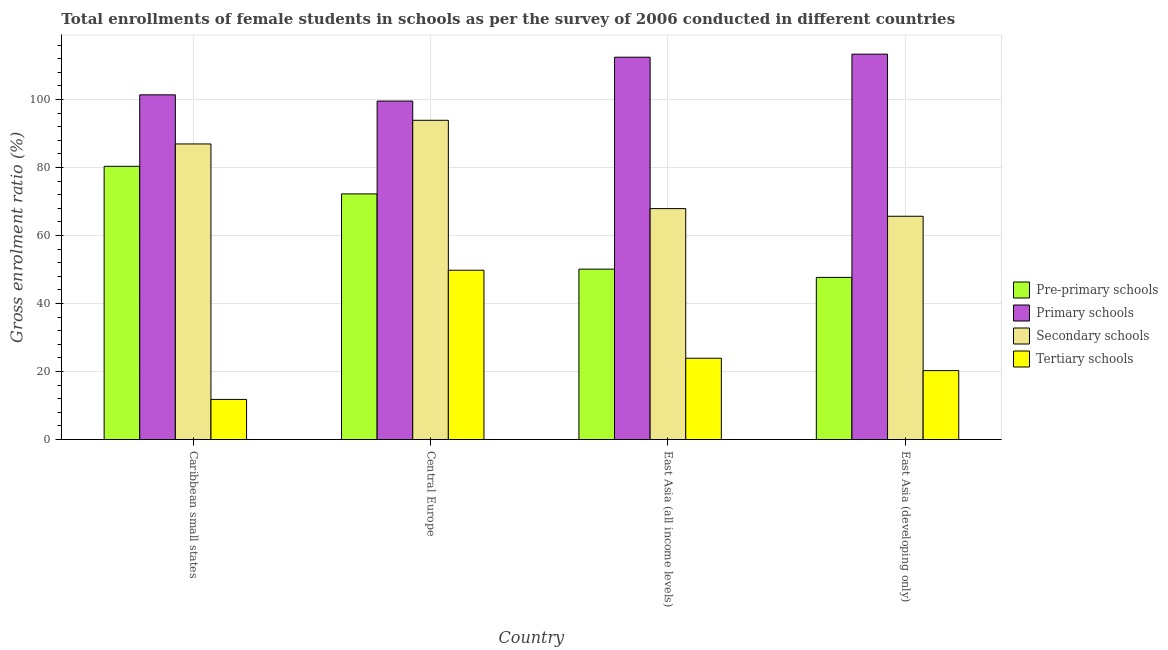Are the number of bars per tick equal to the number of legend labels?
Your answer should be very brief. Yes. How many bars are there on the 1st tick from the right?
Offer a very short reply. 4. What is the label of the 2nd group of bars from the left?
Your answer should be very brief. Central Europe. What is the gross enrolment ratio(female) in primary schools in Central Europe?
Ensure brevity in your answer.  99.56. Across all countries, what is the maximum gross enrolment ratio(female) in secondary schools?
Your answer should be compact. 93.9. Across all countries, what is the minimum gross enrolment ratio(female) in pre-primary schools?
Your response must be concise. 47.69. In which country was the gross enrolment ratio(female) in pre-primary schools maximum?
Ensure brevity in your answer.  Caribbean small states. In which country was the gross enrolment ratio(female) in pre-primary schools minimum?
Make the answer very short. East Asia (developing only). What is the total gross enrolment ratio(female) in tertiary schools in the graph?
Keep it short and to the point. 105.78. What is the difference between the gross enrolment ratio(female) in tertiary schools in Central Europe and that in East Asia (developing only)?
Keep it short and to the point. 29.52. What is the difference between the gross enrolment ratio(female) in primary schools in East Asia (developing only) and the gross enrolment ratio(female) in secondary schools in Central Europe?
Your answer should be very brief. 19.46. What is the average gross enrolment ratio(female) in pre-primary schools per country?
Your answer should be compact. 62.61. What is the difference between the gross enrolment ratio(female) in secondary schools and gross enrolment ratio(female) in primary schools in Caribbean small states?
Ensure brevity in your answer.  -14.45. In how many countries, is the gross enrolment ratio(female) in tertiary schools greater than 96 %?
Give a very brief answer. 0. What is the ratio of the gross enrolment ratio(female) in secondary schools in Caribbean small states to that in East Asia (developing only)?
Give a very brief answer. 1.32. Is the difference between the gross enrolment ratio(female) in tertiary schools in Caribbean small states and East Asia (all income levels) greater than the difference between the gross enrolment ratio(female) in secondary schools in Caribbean small states and East Asia (all income levels)?
Provide a succinct answer. No. What is the difference between the highest and the second highest gross enrolment ratio(female) in secondary schools?
Offer a very short reply. 6.96. What is the difference between the highest and the lowest gross enrolment ratio(female) in secondary schools?
Make the answer very short. 28.23. In how many countries, is the gross enrolment ratio(female) in tertiary schools greater than the average gross enrolment ratio(female) in tertiary schools taken over all countries?
Your response must be concise. 1. Is it the case that in every country, the sum of the gross enrolment ratio(female) in tertiary schools and gross enrolment ratio(female) in secondary schools is greater than the sum of gross enrolment ratio(female) in primary schools and gross enrolment ratio(female) in pre-primary schools?
Make the answer very short. No. What does the 3rd bar from the left in Central Europe represents?
Provide a short and direct response. Secondary schools. What does the 1st bar from the right in East Asia (developing only) represents?
Your response must be concise. Tertiary schools. How many countries are there in the graph?
Provide a succinct answer. 4. What is the difference between two consecutive major ticks on the Y-axis?
Your answer should be very brief. 20. Are the values on the major ticks of Y-axis written in scientific E-notation?
Your answer should be very brief. No. Where does the legend appear in the graph?
Make the answer very short. Center right. How are the legend labels stacked?
Give a very brief answer. Vertical. What is the title of the graph?
Provide a succinct answer. Total enrollments of female students in schools as per the survey of 2006 conducted in different countries. Does "Denmark" appear as one of the legend labels in the graph?
Give a very brief answer. No. What is the label or title of the X-axis?
Ensure brevity in your answer.  Country. What is the Gross enrolment ratio (%) of Pre-primary schools in Caribbean small states?
Offer a very short reply. 80.36. What is the Gross enrolment ratio (%) of Primary schools in Caribbean small states?
Make the answer very short. 101.39. What is the Gross enrolment ratio (%) of Secondary schools in Caribbean small states?
Give a very brief answer. 86.95. What is the Gross enrolment ratio (%) of Tertiary schools in Caribbean small states?
Offer a very short reply. 11.8. What is the Gross enrolment ratio (%) in Pre-primary schools in Central Europe?
Your answer should be compact. 72.25. What is the Gross enrolment ratio (%) in Primary schools in Central Europe?
Your response must be concise. 99.56. What is the Gross enrolment ratio (%) in Secondary schools in Central Europe?
Offer a very short reply. 93.9. What is the Gross enrolment ratio (%) of Tertiary schools in Central Europe?
Make the answer very short. 49.8. What is the Gross enrolment ratio (%) of Pre-primary schools in East Asia (all income levels)?
Give a very brief answer. 50.12. What is the Gross enrolment ratio (%) of Primary schools in East Asia (all income levels)?
Your answer should be very brief. 112.46. What is the Gross enrolment ratio (%) in Secondary schools in East Asia (all income levels)?
Your response must be concise. 67.93. What is the Gross enrolment ratio (%) of Tertiary schools in East Asia (all income levels)?
Your answer should be very brief. 23.91. What is the Gross enrolment ratio (%) in Pre-primary schools in East Asia (developing only)?
Your answer should be compact. 47.69. What is the Gross enrolment ratio (%) of Primary schools in East Asia (developing only)?
Give a very brief answer. 113.36. What is the Gross enrolment ratio (%) in Secondary schools in East Asia (developing only)?
Provide a short and direct response. 65.67. What is the Gross enrolment ratio (%) in Tertiary schools in East Asia (developing only)?
Your answer should be compact. 20.27. Across all countries, what is the maximum Gross enrolment ratio (%) in Pre-primary schools?
Offer a very short reply. 80.36. Across all countries, what is the maximum Gross enrolment ratio (%) in Primary schools?
Your answer should be compact. 113.36. Across all countries, what is the maximum Gross enrolment ratio (%) in Secondary schools?
Your answer should be very brief. 93.9. Across all countries, what is the maximum Gross enrolment ratio (%) in Tertiary schools?
Give a very brief answer. 49.8. Across all countries, what is the minimum Gross enrolment ratio (%) of Pre-primary schools?
Your answer should be compact. 47.69. Across all countries, what is the minimum Gross enrolment ratio (%) of Primary schools?
Provide a succinct answer. 99.56. Across all countries, what is the minimum Gross enrolment ratio (%) in Secondary schools?
Offer a terse response. 65.67. Across all countries, what is the minimum Gross enrolment ratio (%) in Tertiary schools?
Your response must be concise. 11.8. What is the total Gross enrolment ratio (%) of Pre-primary schools in the graph?
Give a very brief answer. 250.43. What is the total Gross enrolment ratio (%) in Primary schools in the graph?
Make the answer very short. 426.78. What is the total Gross enrolment ratio (%) of Secondary schools in the graph?
Offer a terse response. 314.45. What is the total Gross enrolment ratio (%) in Tertiary schools in the graph?
Provide a short and direct response. 105.78. What is the difference between the Gross enrolment ratio (%) in Pre-primary schools in Caribbean small states and that in Central Europe?
Offer a terse response. 8.11. What is the difference between the Gross enrolment ratio (%) of Primary schools in Caribbean small states and that in Central Europe?
Provide a short and direct response. 1.83. What is the difference between the Gross enrolment ratio (%) in Secondary schools in Caribbean small states and that in Central Europe?
Your answer should be compact. -6.96. What is the difference between the Gross enrolment ratio (%) in Tertiary schools in Caribbean small states and that in Central Europe?
Keep it short and to the point. -38. What is the difference between the Gross enrolment ratio (%) in Pre-primary schools in Caribbean small states and that in East Asia (all income levels)?
Provide a succinct answer. 30.25. What is the difference between the Gross enrolment ratio (%) of Primary schools in Caribbean small states and that in East Asia (all income levels)?
Your response must be concise. -11.07. What is the difference between the Gross enrolment ratio (%) in Secondary schools in Caribbean small states and that in East Asia (all income levels)?
Make the answer very short. 19.02. What is the difference between the Gross enrolment ratio (%) in Tertiary schools in Caribbean small states and that in East Asia (all income levels)?
Keep it short and to the point. -12.11. What is the difference between the Gross enrolment ratio (%) in Pre-primary schools in Caribbean small states and that in East Asia (developing only)?
Provide a succinct answer. 32.67. What is the difference between the Gross enrolment ratio (%) of Primary schools in Caribbean small states and that in East Asia (developing only)?
Your response must be concise. -11.97. What is the difference between the Gross enrolment ratio (%) in Secondary schools in Caribbean small states and that in East Asia (developing only)?
Your response must be concise. 21.27. What is the difference between the Gross enrolment ratio (%) of Tertiary schools in Caribbean small states and that in East Asia (developing only)?
Offer a terse response. -8.48. What is the difference between the Gross enrolment ratio (%) of Pre-primary schools in Central Europe and that in East Asia (all income levels)?
Give a very brief answer. 22.13. What is the difference between the Gross enrolment ratio (%) in Primary schools in Central Europe and that in East Asia (all income levels)?
Offer a very short reply. -12.9. What is the difference between the Gross enrolment ratio (%) in Secondary schools in Central Europe and that in East Asia (all income levels)?
Your answer should be compact. 25.98. What is the difference between the Gross enrolment ratio (%) of Tertiary schools in Central Europe and that in East Asia (all income levels)?
Offer a terse response. 25.89. What is the difference between the Gross enrolment ratio (%) in Pre-primary schools in Central Europe and that in East Asia (developing only)?
Your answer should be very brief. 24.56. What is the difference between the Gross enrolment ratio (%) in Primary schools in Central Europe and that in East Asia (developing only)?
Your response must be concise. -13.8. What is the difference between the Gross enrolment ratio (%) in Secondary schools in Central Europe and that in East Asia (developing only)?
Provide a succinct answer. 28.23. What is the difference between the Gross enrolment ratio (%) of Tertiary schools in Central Europe and that in East Asia (developing only)?
Your answer should be compact. 29.52. What is the difference between the Gross enrolment ratio (%) in Pre-primary schools in East Asia (all income levels) and that in East Asia (developing only)?
Provide a succinct answer. 2.43. What is the difference between the Gross enrolment ratio (%) in Primary schools in East Asia (all income levels) and that in East Asia (developing only)?
Offer a very short reply. -0.9. What is the difference between the Gross enrolment ratio (%) of Secondary schools in East Asia (all income levels) and that in East Asia (developing only)?
Ensure brevity in your answer.  2.25. What is the difference between the Gross enrolment ratio (%) in Tertiary schools in East Asia (all income levels) and that in East Asia (developing only)?
Your answer should be very brief. 3.64. What is the difference between the Gross enrolment ratio (%) in Pre-primary schools in Caribbean small states and the Gross enrolment ratio (%) in Primary schools in Central Europe?
Provide a short and direct response. -19.2. What is the difference between the Gross enrolment ratio (%) in Pre-primary schools in Caribbean small states and the Gross enrolment ratio (%) in Secondary schools in Central Europe?
Provide a succinct answer. -13.54. What is the difference between the Gross enrolment ratio (%) of Pre-primary schools in Caribbean small states and the Gross enrolment ratio (%) of Tertiary schools in Central Europe?
Keep it short and to the point. 30.57. What is the difference between the Gross enrolment ratio (%) in Primary schools in Caribbean small states and the Gross enrolment ratio (%) in Secondary schools in Central Europe?
Offer a very short reply. 7.49. What is the difference between the Gross enrolment ratio (%) in Primary schools in Caribbean small states and the Gross enrolment ratio (%) in Tertiary schools in Central Europe?
Your answer should be very brief. 51.6. What is the difference between the Gross enrolment ratio (%) in Secondary schools in Caribbean small states and the Gross enrolment ratio (%) in Tertiary schools in Central Europe?
Keep it short and to the point. 37.15. What is the difference between the Gross enrolment ratio (%) of Pre-primary schools in Caribbean small states and the Gross enrolment ratio (%) of Primary schools in East Asia (all income levels)?
Ensure brevity in your answer.  -32.1. What is the difference between the Gross enrolment ratio (%) in Pre-primary schools in Caribbean small states and the Gross enrolment ratio (%) in Secondary schools in East Asia (all income levels)?
Offer a terse response. 12.44. What is the difference between the Gross enrolment ratio (%) of Pre-primary schools in Caribbean small states and the Gross enrolment ratio (%) of Tertiary schools in East Asia (all income levels)?
Make the answer very short. 56.45. What is the difference between the Gross enrolment ratio (%) of Primary schools in Caribbean small states and the Gross enrolment ratio (%) of Secondary schools in East Asia (all income levels)?
Keep it short and to the point. 33.47. What is the difference between the Gross enrolment ratio (%) of Primary schools in Caribbean small states and the Gross enrolment ratio (%) of Tertiary schools in East Asia (all income levels)?
Offer a terse response. 77.48. What is the difference between the Gross enrolment ratio (%) of Secondary schools in Caribbean small states and the Gross enrolment ratio (%) of Tertiary schools in East Asia (all income levels)?
Make the answer very short. 63.04. What is the difference between the Gross enrolment ratio (%) in Pre-primary schools in Caribbean small states and the Gross enrolment ratio (%) in Primary schools in East Asia (developing only)?
Ensure brevity in your answer.  -33. What is the difference between the Gross enrolment ratio (%) of Pre-primary schools in Caribbean small states and the Gross enrolment ratio (%) of Secondary schools in East Asia (developing only)?
Offer a terse response. 14.69. What is the difference between the Gross enrolment ratio (%) of Pre-primary schools in Caribbean small states and the Gross enrolment ratio (%) of Tertiary schools in East Asia (developing only)?
Provide a succinct answer. 60.09. What is the difference between the Gross enrolment ratio (%) of Primary schools in Caribbean small states and the Gross enrolment ratio (%) of Secondary schools in East Asia (developing only)?
Offer a very short reply. 35.72. What is the difference between the Gross enrolment ratio (%) in Primary schools in Caribbean small states and the Gross enrolment ratio (%) in Tertiary schools in East Asia (developing only)?
Your response must be concise. 81.12. What is the difference between the Gross enrolment ratio (%) in Secondary schools in Caribbean small states and the Gross enrolment ratio (%) in Tertiary schools in East Asia (developing only)?
Offer a terse response. 66.67. What is the difference between the Gross enrolment ratio (%) in Pre-primary schools in Central Europe and the Gross enrolment ratio (%) in Primary schools in East Asia (all income levels)?
Your answer should be very brief. -40.21. What is the difference between the Gross enrolment ratio (%) in Pre-primary schools in Central Europe and the Gross enrolment ratio (%) in Secondary schools in East Asia (all income levels)?
Your answer should be very brief. 4.33. What is the difference between the Gross enrolment ratio (%) in Pre-primary schools in Central Europe and the Gross enrolment ratio (%) in Tertiary schools in East Asia (all income levels)?
Ensure brevity in your answer.  48.34. What is the difference between the Gross enrolment ratio (%) in Primary schools in Central Europe and the Gross enrolment ratio (%) in Secondary schools in East Asia (all income levels)?
Give a very brief answer. 31.64. What is the difference between the Gross enrolment ratio (%) of Primary schools in Central Europe and the Gross enrolment ratio (%) of Tertiary schools in East Asia (all income levels)?
Make the answer very short. 75.65. What is the difference between the Gross enrolment ratio (%) of Secondary schools in Central Europe and the Gross enrolment ratio (%) of Tertiary schools in East Asia (all income levels)?
Give a very brief answer. 69.99. What is the difference between the Gross enrolment ratio (%) in Pre-primary schools in Central Europe and the Gross enrolment ratio (%) in Primary schools in East Asia (developing only)?
Provide a succinct answer. -41.11. What is the difference between the Gross enrolment ratio (%) of Pre-primary schools in Central Europe and the Gross enrolment ratio (%) of Secondary schools in East Asia (developing only)?
Make the answer very short. 6.58. What is the difference between the Gross enrolment ratio (%) of Pre-primary schools in Central Europe and the Gross enrolment ratio (%) of Tertiary schools in East Asia (developing only)?
Ensure brevity in your answer.  51.98. What is the difference between the Gross enrolment ratio (%) of Primary schools in Central Europe and the Gross enrolment ratio (%) of Secondary schools in East Asia (developing only)?
Make the answer very short. 33.89. What is the difference between the Gross enrolment ratio (%) in Primary schools in Central Europe and the Gross enrolment ratio (%) in Tertiary schools in East Asia (developing only)?
Provide a succinct answer. 79.29. What is the difference between the Gross enrolment ratio (%) of Secondary schools in Central Europe and the Gross enrolment ratio (%) of Tertiary schools in East Asia (developing only)?
Give a very brief answer. 73.63. What is the difference between the Gross enrolment ratio (%) of Pre-primary schools in East Asia (all income levels) and the Gross enrolment ratio (%) of Primary schools in East Asia (developing only)?
Provide a succinct answer. -63.24. What is the difference between the Gross enrolment ratio (%) of Pre-primary schools in East Asia (all income levels) and the Gross enrolment ratio (%) of Secondary schools in East Asia (developing only)?
Your answer should be compact. -15.56. What is the difference between the Gross enrolment ratio (%) of Pre-primary schools in East Asia (all income levels) and the Gross enrolment ratio (%) of Tertiary schools in East Asia (developing only)?
Your response must be concise. 29.84. What is the difference between the Gross enrolment ratio (%) of Primary schools in East Asia (all income levels) and the Gross enrolment ratio (%) of Secondary schools in East Asia (developing only)?
Your answer should be compact. 46.79. What is the difference between the Gross enrolment ratio (%) in Primary schools in East Asia (all income levels) and the Gross enrolment ratio (%) in Tertiary schools in East Asia (developing only)?
Your answer should be very brief. 92.19. What is the difference between the Gross enrolment ratio (%) in Secondary schools in East Asia (all income levels) and the Gross enrolment ratio (%) in Tertiary schools in East Asia (developing only)?
Offer a terse response. 47.65. What is the average Gross enrolment ratio (%) of Pre-primary schools per country?
Offer a terse response. 62.61. What is the average Gross enrolment ratio (%) in Primary schools per country?
Your response must be concise. 106.7. What is the average Gross enrolment ratio (%) of Secondary schools per country?
Your answer should be very brief. 78.61. What is the average Gross enrolment ratio (%) of Tertiary schools per country?
Ensure brevity in your answer.  26.45. What is the difference between the Gross enrolment ratio (%) of Pre-primary schools and Gross enrolment ratio (%) of Primary schools in Caribbean small states?
Offer a very short reply. -21.03. What is the difference between the Gross enrolment ratio (%) of Pre-primary schools and Gross enrolment ratio (%) of Secondary schools in Caribbean small states?
Keep it short and to the point. -6.58. What is the difference between the Gross enrolment ratio (%) in Pre-primary schools and Gross enrolment ratio (%) in Tertiary schools in Caribbean small states?
Give a very brief answer. 68.57. What is the difference between the Gross enrolment ratio (%) in Primary schools and Gross enrolment ratio (%) in Secondary schools in Caribbean small states?
Keep it short and to the point. 14.45. What is the difference between the Gross enrolment ratio (%) of Primary schools and Gross enrolment ratio (%) of Tertiary schools in Caribbean small states?
Provide a short and direct response. 89.6. What is the difference between the Gross enrolment ratio (%) of Secondary schools and Gross enrolment ratio (%) of Tertiary schools in Caribbean small states?
Ensure brevity in your answer.  75.15. What is the difference between the Gross enrolment ratio (%) in Pre-primary schools and Gross enrolment ratio (%) in Primary schools in Central Europe?
Make the answer very short. -27.31. What is the difference between the Gross enrolment ratio (%) in Pre-primary schools and Gross enrolment ratio (%) in Secondary schools in Central Europe?
Provide a short and direct response. -21.65. What is the difference between the Gross enrolment ratio (%) in Pre-primary schools and Gross enrolment ratio (%) in Tertiary schools in Central Europe?
Offer a terse response. 22.45. What is the difference between the Gross enrolment ratio (%) of Primary schools and Gross enrolment ratio (%) of Secondary schools in Central Europe?
Ensure brevity in your answer.  5.66. What is the difference between the Gross enrolment ratio (%) in Primary schools and Gross enrolment ratio (%) in Tertiary schools in Central Europe?
Give a very brief answer. 49.77. What is the difference between the Gross enrolment ratio (%) of Secondary schools and Gross enrolment ratio (%) of Tertiary schools in Central Europe?
Keep it short and to the point. 44.11. What is the difference between the Gross enrolment ratio (%) of Pre-primary schools and Gross enrolment ratio (%) of Primary schools in East Asia (all income levels)?
Keep it short and to the point. -62.34. What is the difference between the Gross enrolment ratio (%) in Pre-primary schools and Gross enrolment ratio (%) in Secondary schools in East Asia (all income levels)?
Keep it short and to the point. -17.81. What is the difference between the Gross enrolment ratio (%) of Pre-primary schools and Gross enrolment ratio (%) of Tertiary schools in East Asia (all income levels)?
Your response must be concise. 26.21. What is the difference between the Gross enrolment ratio (%) in Primary schools and Gross enrolment ratio (%) in Secondary schools in East Asia (all income levels)?
Your answer should be very brief. 44.54. What is the difference between the Gross enrolment ratio (%) of Primary schools and Gross enrolment ratio (%) of Tertiary schools in East Asia (all income levels)?
Offer a terse response. 88.55. What is the difference between the Gross enrolment ratio (%) of Secondary schools and Gross enrolment ratio (%) of Tertiary schools in East Asia (all income levels)?
Make the answer very short. 44.01. What is the difference between the Gross enrolment ratio (%) in Pre-primary schools and Gross enrolment ratio (%) in Primary schools in East Asia (developing only)?
Your response must be concise. -65.67. What is the difference between the Gross enrolment ratio (%) in Pre-primary schools and Gross enrolment ratio (%) in Secondary schools in East Asia (developing only)?
Your response must be concise. -17.98. What is the difference between the Gross enrolment ratio (%) in Pre-primary schools and Gross enrolment ratio (%) in Tertiary schools in East Asia (developing only)?
Keep it short and to the point. 27.42. What is the difference between the Gross enrolment ratio (%) in Primary schools and Gross enrolment ratio (%) in Secondary schools in East Asia (developing only)?
Give a very brief answer. 47.69. What is the difference between the Gross enrolment ratio (%) in Primary schools and Gross enrolment ratio (%) in Tertiary schools in East Asia (developing only)?
Keep it short and to the point. 93.09. What is the difference between the Gross enrolment ratio (%) in Secondary schools and Gross enrolment ratio (%) in Tertiary schools in East Asia (developing only)?
Ensure brevity in your answer.  45.4. What is the ratio of the Gross enrolment ratio (%) in Pre-primary schools in Caribbean small states to that in Central Europe?
Your response must be concise. 1.11. What is the ratio of the Gross enrolment ratio (%) of Primary schools in Caribbean small states to that in Central Europe?
Keep it short and to the point. 1.02. What is the ratio of the Gross enrolment ratio (%) of Secondary schools in Caribbean small states to that in Central Europe?
Give a very brief answer. 0.93. What is the ratio of the Gross enrolment ratio (%) of Tertiary schools in Caribbean small states to that in Central Europe?
Make the answer very short. 0.24. What is the ratio of the Gross enrolment ratio (%) in Pre-primary schools in Caribbean small states to that in East Asia (all income levels)?
Your response must be concise. 1.6. What is the ratio of the Gross enrolment ratio (%) of Primary schools in Caribbean small states to that in East Asia (all income levels)?
Ensure brevity in your answer.  0.9. What is the ratio of the Gross enrolment ratio (%) in Secondary schools in Caribbean small states to that in East Asia (all income levels)?
Offer a very short reply. 1.28. What is the ratio of the Gross enrolment ratio (%) in Tertiary schools in Caribbean small states to that in East Asia (all income levels)?
Offer a very short reply. 0.49. What is the ratio of the Gross enrolment ratio (%) of Pre-primary schools in Caribbean small states to that in East Asia (developing only)?
Provide a short and direct response. 1.69. What is the ratio of the Gross enrolment ratio (%) in Primary schools in Caribbean small states to that in East Asia (developing only)?
Your answer should be very brief. 0.89. What is the ratio of the Gross enrolment ratio (%) of Secondary schools in Caribbean small states to that in East Asia (developing only)?
Give a very brief answer. 1.32. What is the ratio of the Gross enrolment ratio (%) of Tertiary schools in Caribbean small states to that in East Asia (developing only)?
Provide a succinct answer. 0.58. What is the ratio of the Gross enrolment ratio (%) in Pre-primary schools in Central Europe to that in East Asia (all income levels)?
Provide a succinct answer. 1.44. What is the ratio of the Gross enrolment ratio (%) in Primary schools in Central Europe to that in East Asia (all income levels)?
Ensure brevity in your answer.  0.89. What is the ratio of the Gross enrolment ratio (%) in Secondary schools in Central Europe to that in East Asia (all income levels)?
Keep it short and to the point. 1.38. What is the ratio of the Gross enrolment ratio (%) in Tertiary schools in Central Europe to that in East Asia (all income levels)?
Ensure brevity in your answer.  2.08. What is the ratio of the Gross enrolment ratio (%) in Pre-primary schools in Central Europe to that in East Asia (developing only)?
Your answer should be compact. 1.51. What is the ratio of the Gross enrolment ratio (%) in Primary schools in Central Europe to that in East Asia (developing only)?
Your answer should be very brief. 0.88. What is the ratio of the Gross enrolment ratio (%) in Secondary schools in Central Europe to that in East Asia (developing only)?
Ensure brevity in your answer.  1.43. What is the ratio of the Gross enrolment ratio (%) of Tertiary schools in Central Europe to that in East Asia (developing only)?
Your response must be concise. 2.46. What is the ratio of the Gross enrolment ratio (%) in Pre-primary schools in East Asia (all income levels) to that in East Asia (developing only)?
Your answer should be compact. 1.05. What is the ratio of the Gross enrolment ratio (%) in Primary schools in East Asia (all income levels) to that in East Asia (developing only)?
Ensure brevity in your answer.  0.99. What is the ratio of the Gross enrolment ratio (%) of Secondary schools in East Asia (all income levels) to that in East Asia (developing only)?
Your response must be concise. 1.03. What is the ratio of the Gross enrolment ratio (%) of Tertiary schools in East Asia (all income levels) to that in East Asia (developing only)?
Provide a short and direct response. 1.18. What is the difference between the highest and the second highest Gross enrolment ratio (%) of Pre-primary schools?
Your answer should be compact. 8.11. What is the difference between the highest and the second highest Gross enrolment ratio (%) of Primary schools?
Offer a terse response. 0.9. What is the difference between the highest and the second highest Gross enrolment ratio (%) of Secondary schools?
Offer a terse response. 6.96. What is the difference between the highest and the second highest Gross enrolment ratio (%) in Tertiary schools?
Your response must be concise. 25.89. What is the difference between the highest and the lowest Gross enrolment ratio (%) in Pre-primary schools?
Offer a very short reply. 32.67. What is the difference between the highest and the lowest Gross enrolment ratio (%) of Primary schools?
Keep it short and to the point. 13.8. What is the difference between the highest and the lowest Gross enrolment ratio (%) in Secondary schools?
Make the answer very short. 28.23. What is the difference between the highest and the lowest Gross enrolment ratio (%) of Tertiary schools?
Offer a very short reply. 38. 